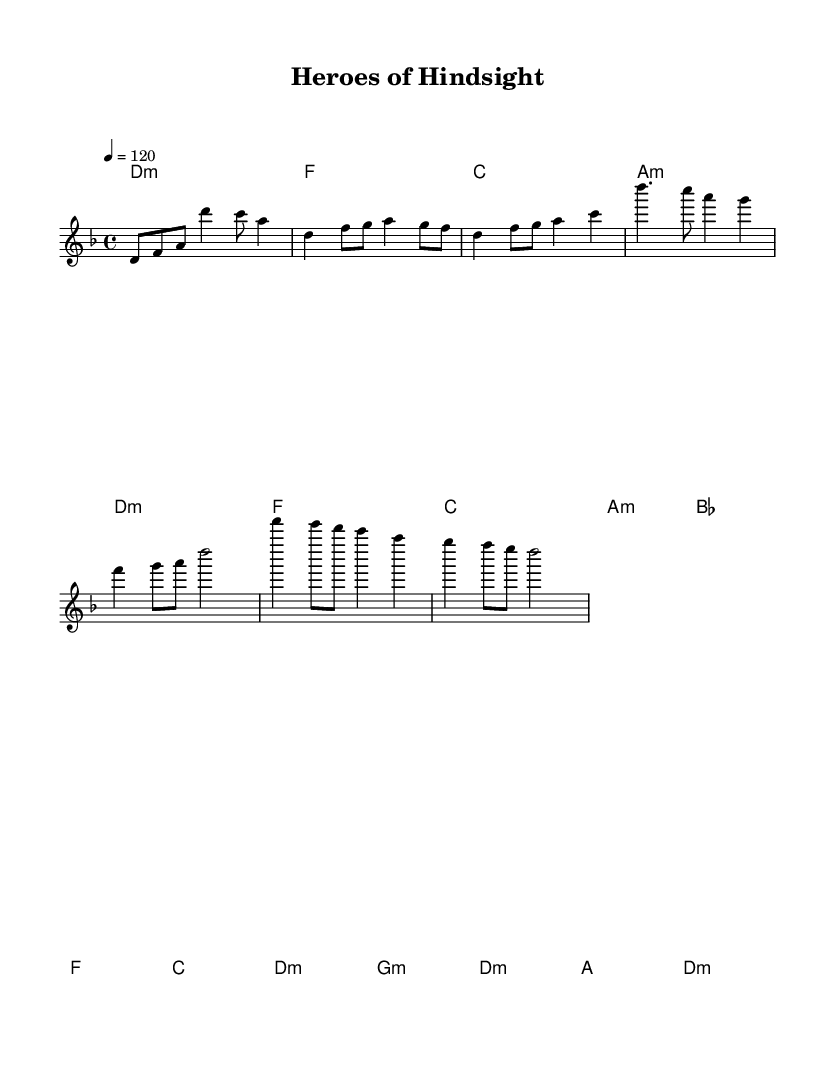What is the key signature of this music? The key signature indicates the tonal center of the piece. In the given sheet music, the key signature marked is D minor, which is represented by one flat (B flat).
Answer: D minor What is the time signature of the piece? The time signature is located at the beginning of the sheet music, indicating how many beats are in each measure. Here, the time signature is 4/4, meaning there are four beats per measure.
Answer: 4/4 What is the tempo marking of the music? The tempo marking indicates how fast the music should be played. In the provided sheet music, the tempo is marked as quarter note equals 120 beats per minute.
Answer: 120 What is the first chord in the introduction? The first chord in the introduction section of the sheet music is indicated by its notation. The chord is labeled as "d1:m", which refers to D minor.
Answer: D minor How many measures are in the chorus section? The chorus section can be identified by the layout and is specifically represented in a grouping of measures. By counting, we see that there are four measures present in the chorus section.
Answer: 4 What is the last chord in the bridge? The last chord of the bridge is noted at the end of that section, where it is represented as "d:m," which corresponds to D minor.
Answer: D minor What three notes are in the melody at the start of the verse? The melody for the verse starts with the notes D, F, and G as indicated at the beginning of that section.
Answer: D, F, G 